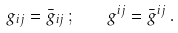Convert formula to latex. <formula><loc_0><loc_0><loc_500><loc_500>g _ { i j } = \bar { g } _ { i j } \, ; \quad g ^ { i j } = \bar { g } ^ { i j } \, .</formula> 